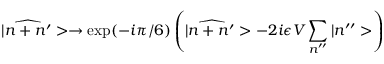<formula> <loc_0><loc_0><loc_500><loc_500>| \widehat { n + n ^ { \prime } } > \rightarrow e x p ( - i \pi / 6 ) \left ( | \widehat { n + n ^ { \prime } } > - 2 i \epsilon V \sum _ { n ^ { \prime \prime } } | n ^ { \prime \prime } > \right )</formula> 